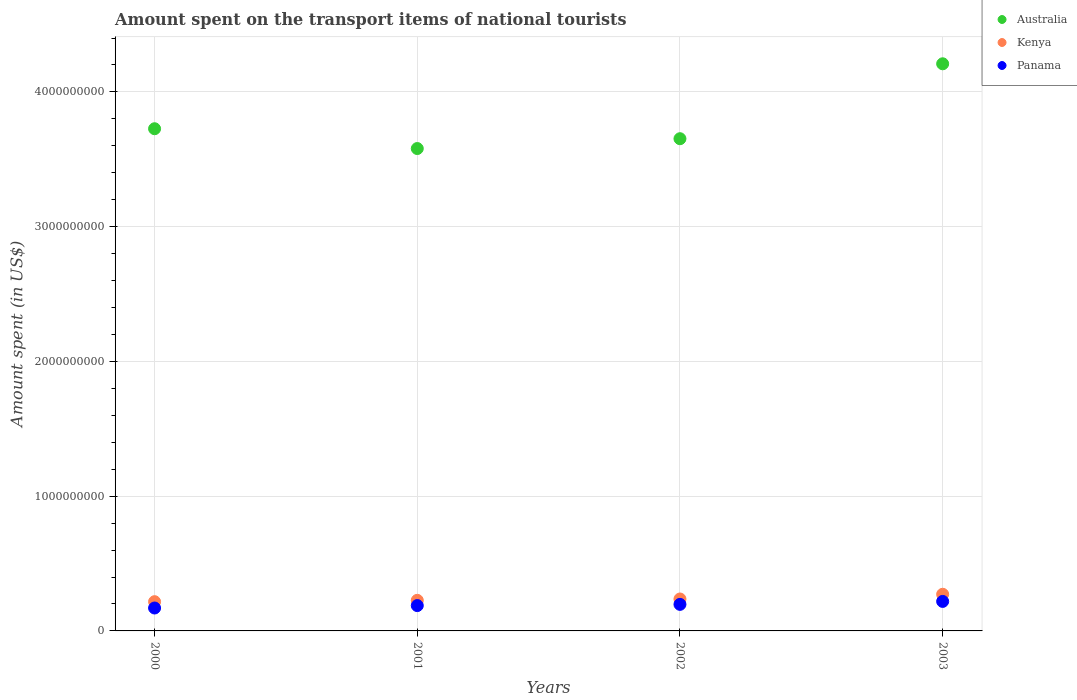How many different coloured dotlines are there?
Provide a short and direct response. 3. Is the number of dotlines equal to the number of legend labels?
Ensure brevity in your answer.  Yes. What is the amount spent on the transport items of national tourists in Kenya in 2002?
Keep it short and to the point. 2.37e+08. Across all years, what is the maximum amount spent on the transport items of national tourists in Kenya?
Provide a succinct answer. 2.72e+08. Across all years, what is the minimum amount spent on the transport items of national tourists in Panama?
Offer a very short reply. 1.70e+08. What is the total amount spent on the transport items of national tourists in Panama in the graph?
Give a very brief answer. 7.74e+08. What is the difference between the amount spent on the transport items of national tourists in Kenya in 2001 and that in 2003?
Offer a very short reply. -4.50e+07. What is the difference between the amount spent on the transport items of national tourists in Panama in 2000 and the amount spent on the transport items of national tourists in Australia in 2001?
Make the answer very short. -3.41e+09. What is the average amount spent on the transport items of national tourists in Kenya per year?
Your response must be concise. 2.38e+08. In the year 2000, what is the difference between the amount spent on the transport items of national tourists in Panama and amount spent on the transport items of national tourists in Australia?
Give a very brief answer. -3.56e+09. In how many years, is the amount spent on the transport items of national tourists in Kenya greater than 600000000 US$?
Make the answer very short. 0. What is the ratio of the amount spent on the transport items of national tourists in Panama in 2001 to that in 2002?
Provide a short and direct response. 0.95. Is the difference between the amount spent on the transport items of national tourists in Panama in 2000 and 2003 greater than the difference between the amount spent on the transport items of national tourists in Australia in 2000 and 2003?
Offer a terse response. Yes. What is the difference between the highest and the second highest amount spent on the transport items of national tourists in Australia?
Your answer should be very brief. 4.82e+08. What is the difference between the highest and the lowest amount spent on the transport items of national tourists in Panama?
Ensure brevity in your answer.  4.90e+07. Is the amount spent on the transport items of national tourists in Australia strictly less than the amount spent on the transport items of national tourists in Kenya over the years?
Provide a succinct answer. No. How many dotlines are there?
Your answer should be very brief. 3. Are the values on the major ticks of Y-axis written in scientific E-notation?
Give a very brief answer. No. How are the legend labels stacked?
Your answer should be compact. Vertical. What is the title of the graph?
Your answer should be very brief. Amount spent on the transport items of national tourists. Does "Cyprus" appear as one of the legend labels in the graph?
Make the answer very short. No. What is the label or title of the X-axis?
Give a very brief answer. Years. What is the label or title of the Y-axis?
Provide a succinct answer. Amount spent (in US$). What is the Amount spent (in US$) in Australia in 2000?
Provide a short and direct response. 3.73e+09. What is the Amount spent (in US$) in Kenya in 2000?
Provide a short and direct response. 2.17e+08. What is the Amount spent (in US$) of Panama in 2000?
Offer a very short reply. 1.70e+08. What is the Amount spent (in US$) of Australia in 2001?
Offer a terse response. 3.58e+09. What is the Amount spent (in US$) of Kenya in 2001?
Make the answer very short. 2.27e+08. What is the Amount spent (in US$) of Panama in 2001?
Your answer should be compact. 1.88e+08. What is the Amount spent (in US$) of Australia in 2002?
Your response must be concise. 3.65e+09. What is the Amount spent (in US$) in Kenya in 2002?
Your answer should be compact. 2.37e+08. What is the Amount spent (in US$) in Panama in 2002?
Ensure brevity in your answer.  1.97e+08. What is the Amount spent (in US$) of Australia in 2003?
Make the answer very short. 4.21e+09. What is the Amount spent (in US$) of Kenya in 2003?
Ensure brevity in your answer.  2.72e+08. What is the Amount spent (in US$) in Panama in 2003?
Make the answer very short. 2.19e+08. Across all years, what is the maximum Amount spent (in US$) of Australia?
Give a very brief answer. 4.21e+09. Across all years, what is the maximum Amount spent (in US$) in Kenya?
Your answer should be very brief. 2.72e+08. Across all years, what is the maximum Amount spent (in US$) in Panama?
Provide a succinct answer. 2.19e+08. Across all years, what is the minimum Amount spent (in US$) in Australia?
Ensure brevity in your answer.  3.58e+09. Across all years, what is the minimum Amount spent (in US$) in Kenya?
Your response must be concise. 2.17e+08. Across all years, what is the minimum Amount spent (in US$) in Panama?
Ensure brevity in your answer.  1.70e+08. What is the total Amount spent (in US$) in Australia in the graph?
Provide a succinct answer. 1.52e+1. What is the total Amount spent (in US$) in Kenya in the graph?
Give a very brief answer. 9.53e+08. What is the total Amount spent (in US$) of Panama in the graph?
Keep it short and to the point. 7.74e+08. What is the difference between the Amount spent (in US$) in Australia in 2000 and that in 2001?
Provide a succinct answer. 1.47e+08. What is the difference between the Amount spent (in US$) of Kenya in 2000 and that in 2001?
Your answer should be very brief. -1.00e+07. What is the difference between the Amount spent (in US$) in Panama in 2000 and that in 2001?
Keep it short and to the point. -1.80e+07. What is the difference between the Amount spent (in US$) in Australia in 2000 and that in 2002?
Give a very brief answer. 7.40e+07. What is the difference between the Amount spent (in US$) of Kenya in 2000 and that in 2002?
Your answer should be compact. -2.00e+07. What is the difference between the Amount spent (in US$) of Panama in 2000 and that in 2002?
Give a very brief answer. -2.70e+07. What is the difference between the Amount spent (in US$) of Australia in 2000 and that in 2003?
Give a very brief answer. -4.82e+08. What is the difference between the Amount spent (in US$) in Kenya in 2000 and that in 2003?
Give a very brief answer. -5.50e+07. What is the difference between the Amount spent (in US$) of Panama in 2000 and that in 2003?
Give a very brief answer. -4.90e+07. What is the difference between the Amount spent (in US$) of Australia in 2001 and that in 2002?
Your answer should be compact. -7.30e+07. What is the difference between the Amount spent (in US$) in Kenya in 2001 and that in 2002?
Offer a very short reply. -1.00e+07. What is the difference between the Amount spent (in US$) in Panama in 2001 and that in 2002?
Provide a succinct answer. -9.00e+06. What is the difference between the Amount spent (in US$) in Australia in 2001 and that in 2003?
Your answer should be very brief. -6.29e+08. What is the difference between the Amount spent (in US$) of Kenya in 2001 and that in 2003?
Your response must be concise. -4.50e+07. What is the difference between the Amount spent (in US$) of Panama in 2001 and that in 2003?
Your response must be concise. -3.10e+07. What is the difference between the Amount spent (in US$) of Australia in 2002 and that in 2003?
Make the answer very short. -5.56e+08. What is the difference between the Amount spent (in US$) of Kenya in 2002 and that in 2003?
Give a very brief answer. -3.50e+07. What is the difference between the Amount spent (in US$) of Panama in 2002 and that in 2003?
Give a very brief answer. -2.20e+07. What is the difference between the Amount spent (in US$) in Australia in 2000 and the Amount spent (in US$) in Kenya in 2001?
Keep it short and to the point. 3.50e+09. What is the difference between the Amount spent (in US$) of Australia in 2000 and the Amount spent (in US$) of Panama in 2001?
Provide a succinct answer. 3.54e+09. What is the difference between the Amount spent (in US$) in Kenya in 2000 and the Amount spent (in US$) in Panama in 2001?
Provide a succinct answer. 2.90e+07. What is the difference between the Amount spent (in US$) of Australia in 2000 and the Amount spent (in US$) of Kenya in 2002?
Ensure brevity in your answer.  3.49e+09. What is the difference between the Amount spent (in US$) of Australia in 2000 and the Amount spent (in US$) of Panama in 2002?
Offer a terse response. 3.53e+09. What is the difference between the Amount spent (in US$) of Kenya in 2000 and the Amount spent (in US$) of Panama in 2002?
Make the answer very short. 2.00e+07. What is the difference between the Amount spent (in US$) of Australia in 2000 and the Amount spent (in US$) of Kenya in 2003?
Offer a very short reply. 3.46e+09. What is the difference between the Amount spent (in US$) of Australia in 2000 and the Amount spent (in US$) of Panama in 2003?
Offer a very short reply. 3.51e+09. What is the difference between the Amount spent (in US$) of Australia in 2001 and the Amount spent (in US$) of Kenya in 2002?
Your answer should be very brief. 3.34e+09. What is the difference between the Amount spent (in US$) of Australia in 2001 and the Amount spent (in US$) of Panama in 2002?
Ensure brevity in your answer.  3.38e+09. What is the difference between the Amount spent (in US$) in Kenya in 2001 and the Amount spent (in US$) in Panama in 2002?
Ensure brevity in your answer.  3.00e+07. What is the difference between the Amount spent (in US$) in Australia in 2001 and the Amount spent (in US$) in Kenya in 2003?
Give a very brief answer. 3.31e+09. What is the difference between the Amount spent (in US$) of Australia in 2001 and the Amount spent (in US$) of Panama in 2003?
Give a very brief answer. 3.36e+09. What is the difference between the Amount spent (in US$) of Kenya in 2001 and the Amount spent (in US$) of Panama in 2003?
Your answer should be compact. 8.00e+06. What is the difference between the Amount spent (in US$) in Australia in 2002 and the Amount spent (in US$) in Kenya in 2003?
Ensure brevity in your answer.  3.38e+09. What is the difference between the Amount spent (in US$) of Australia in 2002 and the Amount spent (in US$) of Panama in 2003?
Keep it short and to the point. 3.43e+09. What is the difference between the Amount spent (in US$) in Kenya in 2002 and the Amount spent (in US$) in Panama in 2003?
Ensure brevity in your answer.  1.80e+07. What is the average Amount spent (in US$) in Australia per year?
Offer a very short reply. 3.79e+09. What is the average Amount spent (in US$) in Kenya per year?
Your answer should be compact. 2.38e+08. What is the average Amount spent (in US$) in Panama per year?
Provide a short and direct response. 1.94e+08. In the year 2000, what is the difference between the Amount spent (in US$) in Australia and Amount spent (in US$) in Kenya?
Provide a succinct answer. 3.51e+09. In the year 2000, what is the difference between the Amount spent (in US$) in Australia and Amount spent (in US$) in Panama?
Give a very brief answer. 3.56e+09. In the year 2000, what is the difference between the Amount spent (in US$) in Kenya and Amount spent (in US$) in Panama?
Offer a terse response. 4.70e+07. In the year 2001, what is the difference between the Amount spent (in US$) in Australia and Amount spent (in US$) in Kenya?
Offer a very short reply. 3.35e+09. In the year 2001, what is the difference between the Amount spent (in US$) in Australia and Amount spent (in US$) in Panama?
Give a very brief answer. 3.39e+09. In the year 2001, what is the difference between the Amount spent (in US$) in Kenya and Amount spent (in US$) in Panama?
Your response must be concise. 3.90e+07. In the year 2002, what is the difference between the Amount spent (in US$) in Australia and Amount spent (in US$) in Kenya?
Your answer should be very brief. 3.42e+09. In the year 2002, what is the difference between the Amount spent (in US$) of Australia and Amount spent (in US$) of Panama?
Offer a very short reply. 3.46e+09. In the year 2002, what is the difference between the Amount spent (in US$) of Kenya and Amount spent (in US$) of Panama?
Your response must be concise. 4.00e+07. In the year 2003, what is the difference between the Amount spent (in US$) in Australia and Amount spent (in US$) in Kenya?
Provide a succinct answer. 3.94e+09. In the year 2003, what is the difference between the Amount spent (in US$) of Australia and Amount spent (in US$) of Panama?
Offer a very short reply. 3.99e+09. In the year 2003, what is the difference between the Amount spent (in US$) of Kenya and Amount spent (in US$) of Panama?
Offer a terse response. 5.30e+07. What is the ratio of the Amount spent (in US$) of Australia in 2000 to that in 2001?
Offer a terse response. 1.04. What is the ratio of the Amount spent (in US$) of Kenya in 2000 to that in 2001?
Give a very brief answer. 0.96. What is the ratio of the Amount spent (in US$) of Panama in 2000 to that in 2001?
Make the answer very short. 0.9. What is the ratio of the Amount spent (in US$) in Australia in 2000 to that in 2002?
Your answer should be compact. 1.02. What is the ratio of the Amount spent (in US$) in Kenya in 2000 to that in 2002?
Make the answer very short. 0.92. What is the ratio of the Amount spent (in US$) in Panama in 2000 to that in 2002?
Offer a terse response. 0.86. What is the ratio of the Amount spent (in US$) in Australia in 2000 to that in 2003?
Your response must be concise. 0.89. What is the ratio of the Amount spent (in US$) of Kenya in 2000 to that in 2003?
Your response must be concise. 0.8. What is the ratio of the Amount spent (in US$) of Panama in 2000 to that in 2003?
Your answer should be very brief. 0.78. What is the ratio of the Amount spent (in US$) in Australia in 2001 to that in 2002?
Your answer should be compact. 0.98. What is the ratio of the Amount spent (in US$) in Kenya in 2001 to that in 2002?
Ensure brevity in your answer.  0.96. What is the ratio of the Amount spent (in US$) of Panama in 2001 to that in 2002?
Provide a short and direct response. 0.95. What is the ratio of the Amount spent (in US$) in Australia in 2001 to that in 2003?
Provide a succinct answer. 0.85. What is the ratio of the Amount spent (in US$) of Kenya in 2001 to that in 2003?
Make the answer very short. 0.83. What is the ratio of the Amount spent (in US$) in Panama in 2001 to that in 2003?
Keep it short and to the point. 0.86. What is the ratio of the Amount spent (in US$) in Australia in 2002 to that in 2003?
Your answer should be compact. 0.87. What is the ratio of the Amount spent (in US$) of Kenya in 2002 to that in 2003?
Make the answer very short. 0.87. What is the ratio of the Amount spent (in US$) of Panama in 2002 to that in 2003?
Make the answer very short. 0.9. What is the difference between the highest and the second highest Amount spent (in US$) of Australia?
Provide a succinct answer. 4.82e+08. What is the difference between the highest and the second highest Amount spent (in US$) of Kenya?
Ensure brevity in your answer.  3.50e+07. What is the difference between the highest and the second highest Amount spent (in US$) in Panama?
Offer a terse response. 2.20e+07. What is the difference between the highest and the lowest Amount spent (in US$) in Australia?
Your answer should be compact. 6.29e+08. What is the difference between the highest and the lowest Amount spent (in US$) in Kenya?
Offer a very short reply. 5.50e+07. What is the difference between the highest and the lowest Amount spent (in US$) in Panama?
Offer a terse response. 4.90e+07. 